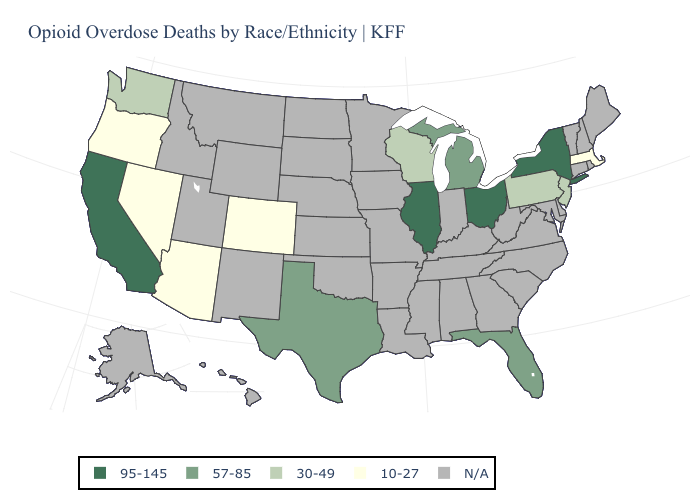What is the value of West Virginia?
Answer briefly. N/A. Name the states that have a value in the range 57-85?
Quick response, please. Florida, Michigan, Texas. Name the states that have a value in the range 30-49?
Concise answer only. New Jersey, Pennsylvania, Washington, Wisconsin. What is the highest value in the Northeast ?
Answer briefly. 95-145. Does the map have missing data?
Give a very brief answer. Yes. Is the legend a continuous bar?
Keep it brief. No. Name the states that have a value in the range N/A?
Short answer required. Alabama, Alaska, Arkansas, Connecticut, Delaware, Georgia, Hawaii, Idaho, Indiana, Iowa, Kansas, Kentucky, Louisiana, Maine, Maryland, Minnesota, Mississippi, Missouri, Montana, Nebraska, New Hampshire, New Mexico, North Carolina, North Dakota, Oklahoma, Rhode Island, South Carolina, South Dakota, Tennessee, Utah, Vermont, Virginia, West Virginia, Wyoming. Name the states that have a value in the range 57-85?
Write a very short answer. Florida, Michigan, Texas. What is the highest value in states that border Oklahoma?
Give a very brief answer. 57-85. Does Massachusetts have the lowest value in the Northeast?
Answer briefly. Yes. Is the legend a continuous bar?
Keep it brief. No. Which states have the lowest value in the Northeast?
Quick response, please. Massachusetts. Which states have the lowest value in the Northeast?
Short answer required. Massachusetts. Name the states that have a value in the range 57-85?
Give a very brief answer. Florida, Michigan, Texas. What is the value of Connecticut?
Write a very short answer. N/A. 